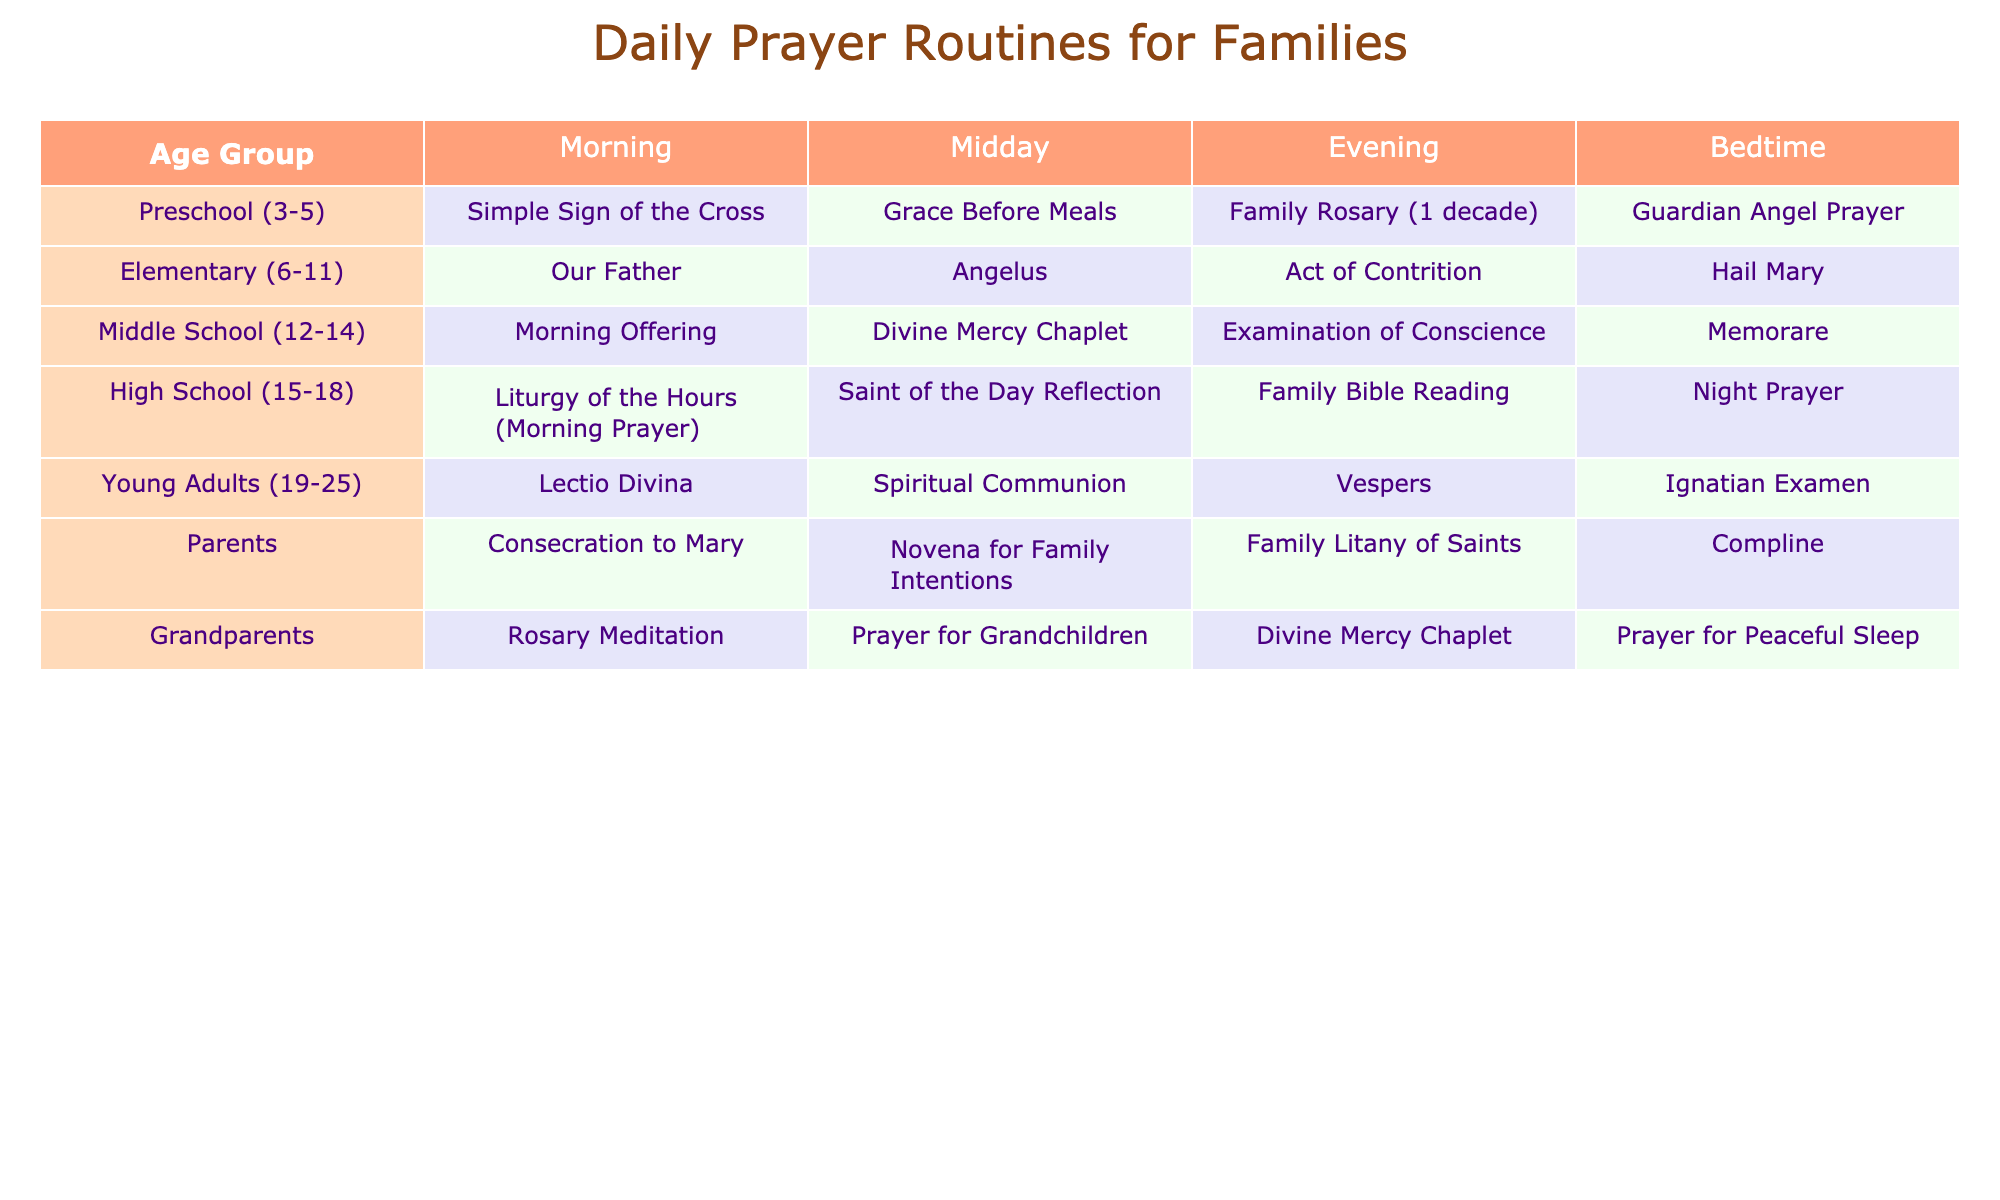What prayer do Preschool age families say during the Midday? According to the table, Preschool age families say "Grace Before Meals" during the Midday prayer time.
Answer: Grace Before Meals Which age group says the Liturgy of the Hours in the morning? The table shows that High School age families (15-18) say the "Liturgy of the Hours (Morning Prayer)" in the morning.
Answer: High School (15-18) Is there a prayer that both Grandparents and Parents say at bedtime? The table states that Grandparents say "Prayer for Peaceful Sleep" and Parents say "Compline" at bedtime, so they do not share a common prayer at this time.
Answer: No What is the total number of different prayers listed for each age group at Midday? Counting the prayers for each age group at Midday: Preschool (1) + Elementary (1) + Middle School (1) + High School (1) + Young Adults (1) + Parents (1) + Grandparents (1) totals to 7 distinct prayers.
Answer: 7 Do Young Adults have a prayer specifically for family intentions? The table indicates that Young Adults do not have a prayer listed for family intentions; this prayer is designated for Parents. Thus, the answer is no.
Answer: No Which age group practices the Divine Mercy Chaplet at more than one time? From the table, we see that the Divine Mercy Chaplet is practiced by Middle School at Evening and Grandparents at Midday, indicating Grandparents practice it twice.
Answer: Grandparents How many distinctive prayers are there for bedtime across all age groups combined? By reviewing the table for bedtime prayers, the counts are: Guardian Angel Prayer (Preschool) + Hail Mary (Elementary) + Memorare (Middle School) + Night Prayer (High School) + Ignatian Examen (Young Adults) + Compline (Parents) + Prayer for Peaceful Sleep (Grandparents). This results in 7 distinct prayers.
Answer: 7 